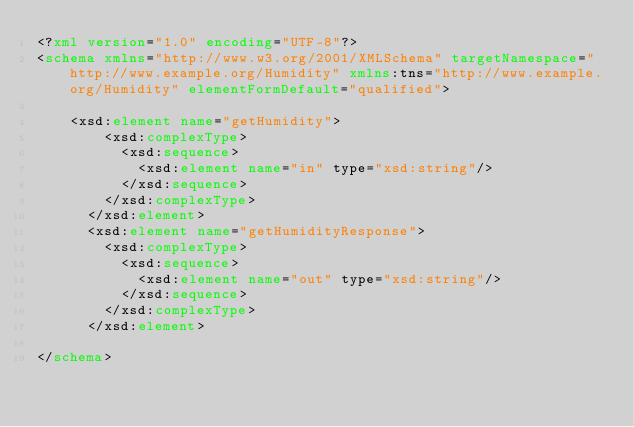<code> <loc_0><loc_0><loc_500><loc_500><_XML_><?xml version="1.0" encoding="UTF-8"?>
<schema xmlns="http://www.w3.org/2001/XMLSchema" targetNamespace="http://www.example.org/Humidity" xmlns:tns="http://www.example.org/Humidity" elementFormDefault="qualified">

	<xsd:element name="getHumidity">
        <xsd:complexType>
          <xsd:sequence>
            <xsd:element name="in" type="xsd:string"/>
          </xsd:sequence>
        </xsd:complexType>
      </xsd:element>
      <xsd:element name="getHumidityResponse">
        <xsd:complexType>
          <xsd:sequence>
            <xsd:element name="out" type="xsd:string"/>
          </xsd:sequence>
        </xsd:complexType>
      </xsd:element>

</schema></code> 